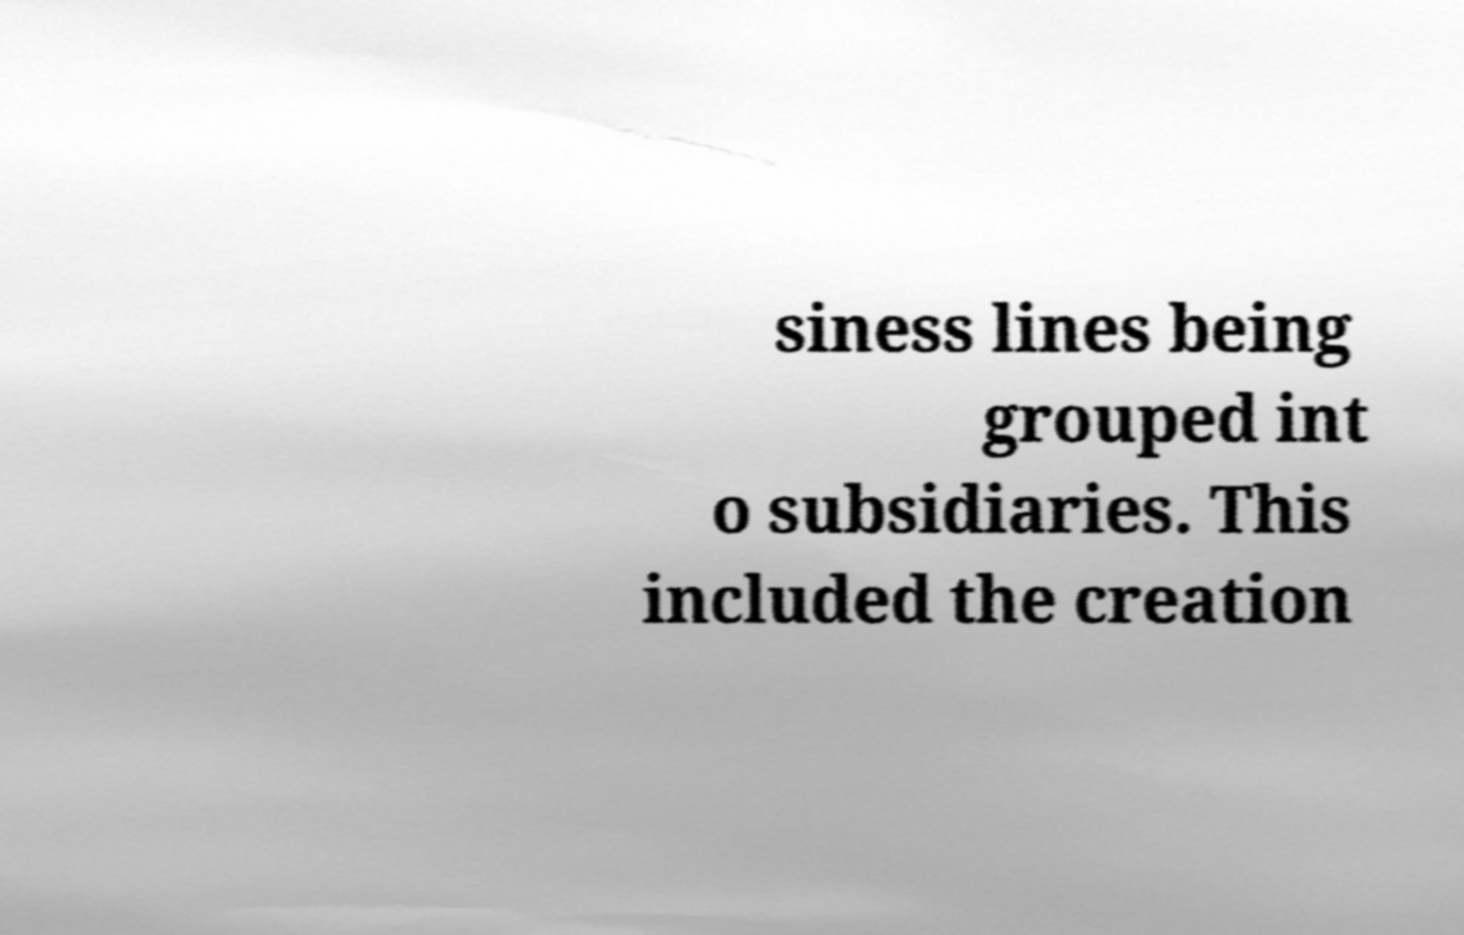What messages or text are displayed in this image? I need them in a readable, typed format. siness lines being grouped int o subsidiaries. This included the creation 